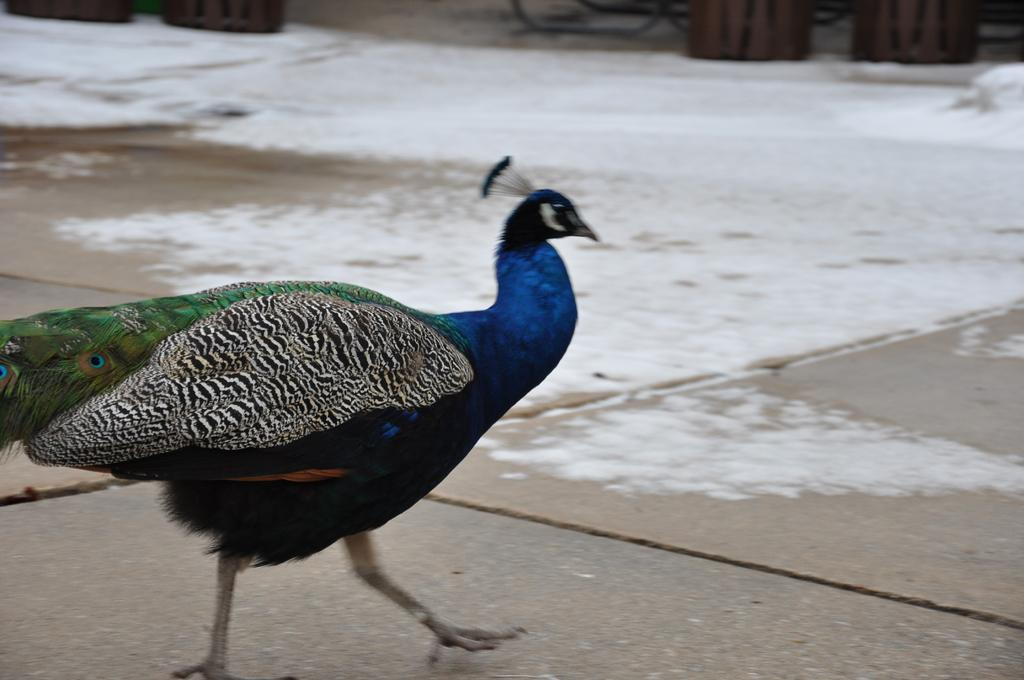What animal is present in the image? There is a peacock in the image. What is the peacock doing in the image? The peacock is walking on the road in the image. What colors can be seen on the peacock? The peacock has green, blue, black, and brown colors. What type of surface is the peacock walking on? There is snow on the floor in the image, so the peacock is walking on snow. Can you see any cobwebs in the image? There is no mention of cobwebs in the image, so we cannot determine if any are present. 